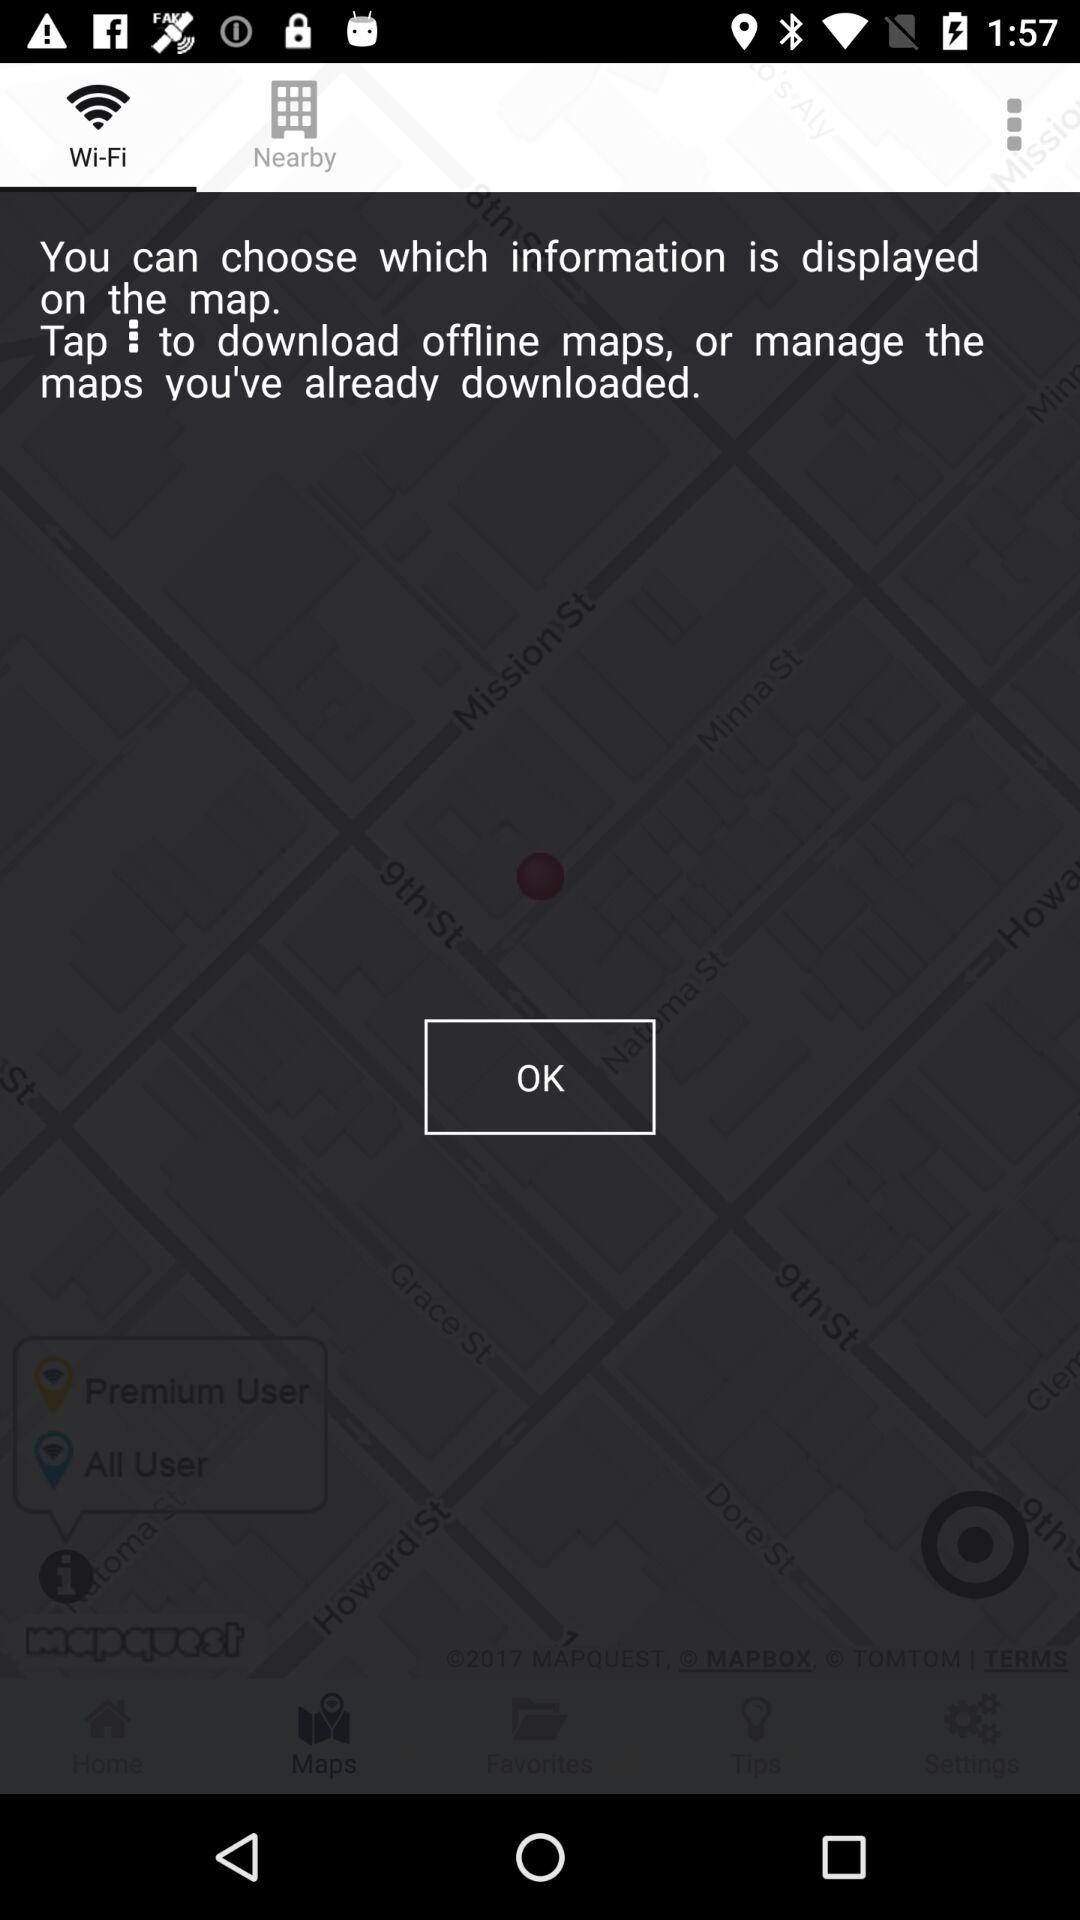Which tab is selected? The selected tab is "Wi-Fi". 